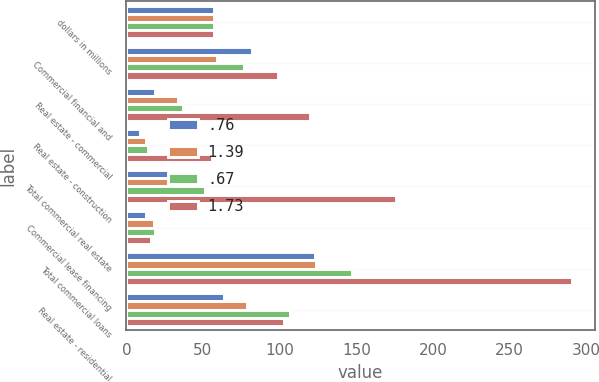<chart> <loc_0><loc_0><loc_500><loc_500><stacked_bar_chart><ecel><fcel>dollars in millions<fcel>Commercial financial and<fcel>Real estate - commercial<fcel>Real estate - construction<fcel>Total commercial real estate<fcel>Commercial lease financing<fcel>Total commercial loans<fcel>Real estate - residential<nl><fcel>0.76<fcel>57.5<fcel>82<fcel>19<fcel>9<fcel>28<fcel>13<fcel>123<fcel>64<nl><fcel>1.39<fcel>57.5<fcel>59<fcel>34<fcel>13<fcel>47<fcel>18<fcel>124<fcel>79<nl><fcel>0.67<fcel>57.5<fcel>77<fcel>37<fcel>14<fcel>51<fcel>19<fcel>147<fcel>107<nl><fcel>1.73<fcel>57.5<fcel>99<fcel>120<fcel>56<fcel>176<fcel>16<fcel>291<fcel>103<nl></chart> 